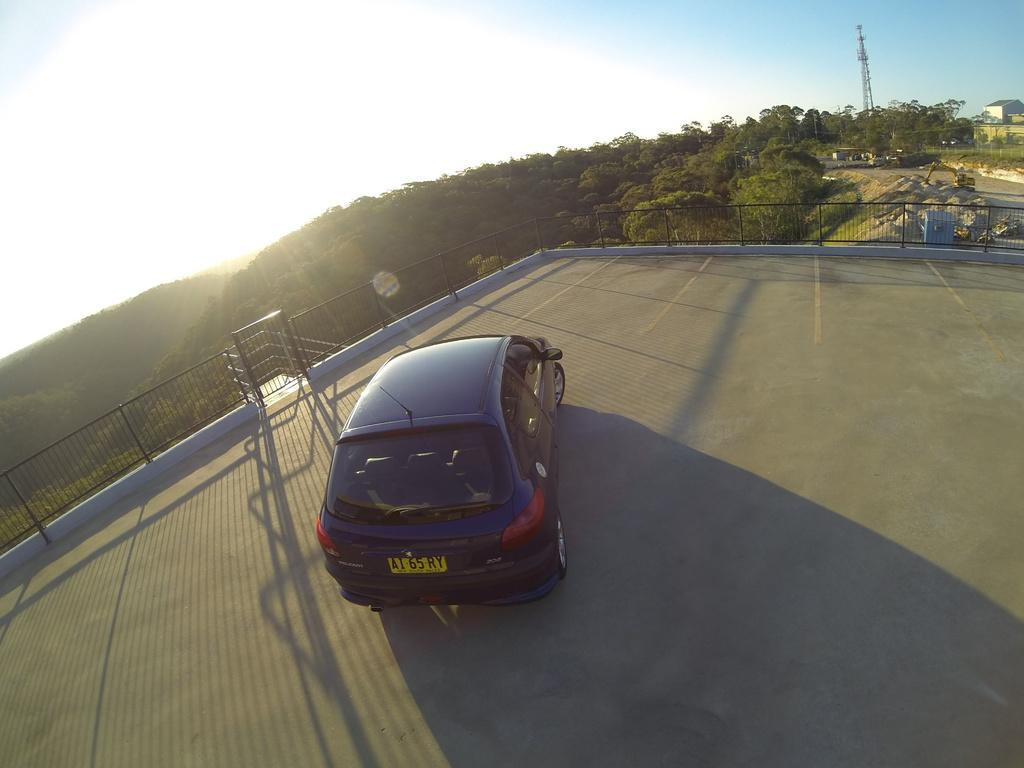What is the main subject of the image? The main subject of the image is a car. What type of natural elements can be seen in the image? There are trees in the image. What is visible at the top of the image? The sky is visible at the top of the image. What type of bread can be seen being used to help the car in the image? There is no bread or any act of helping the car present in the image. 